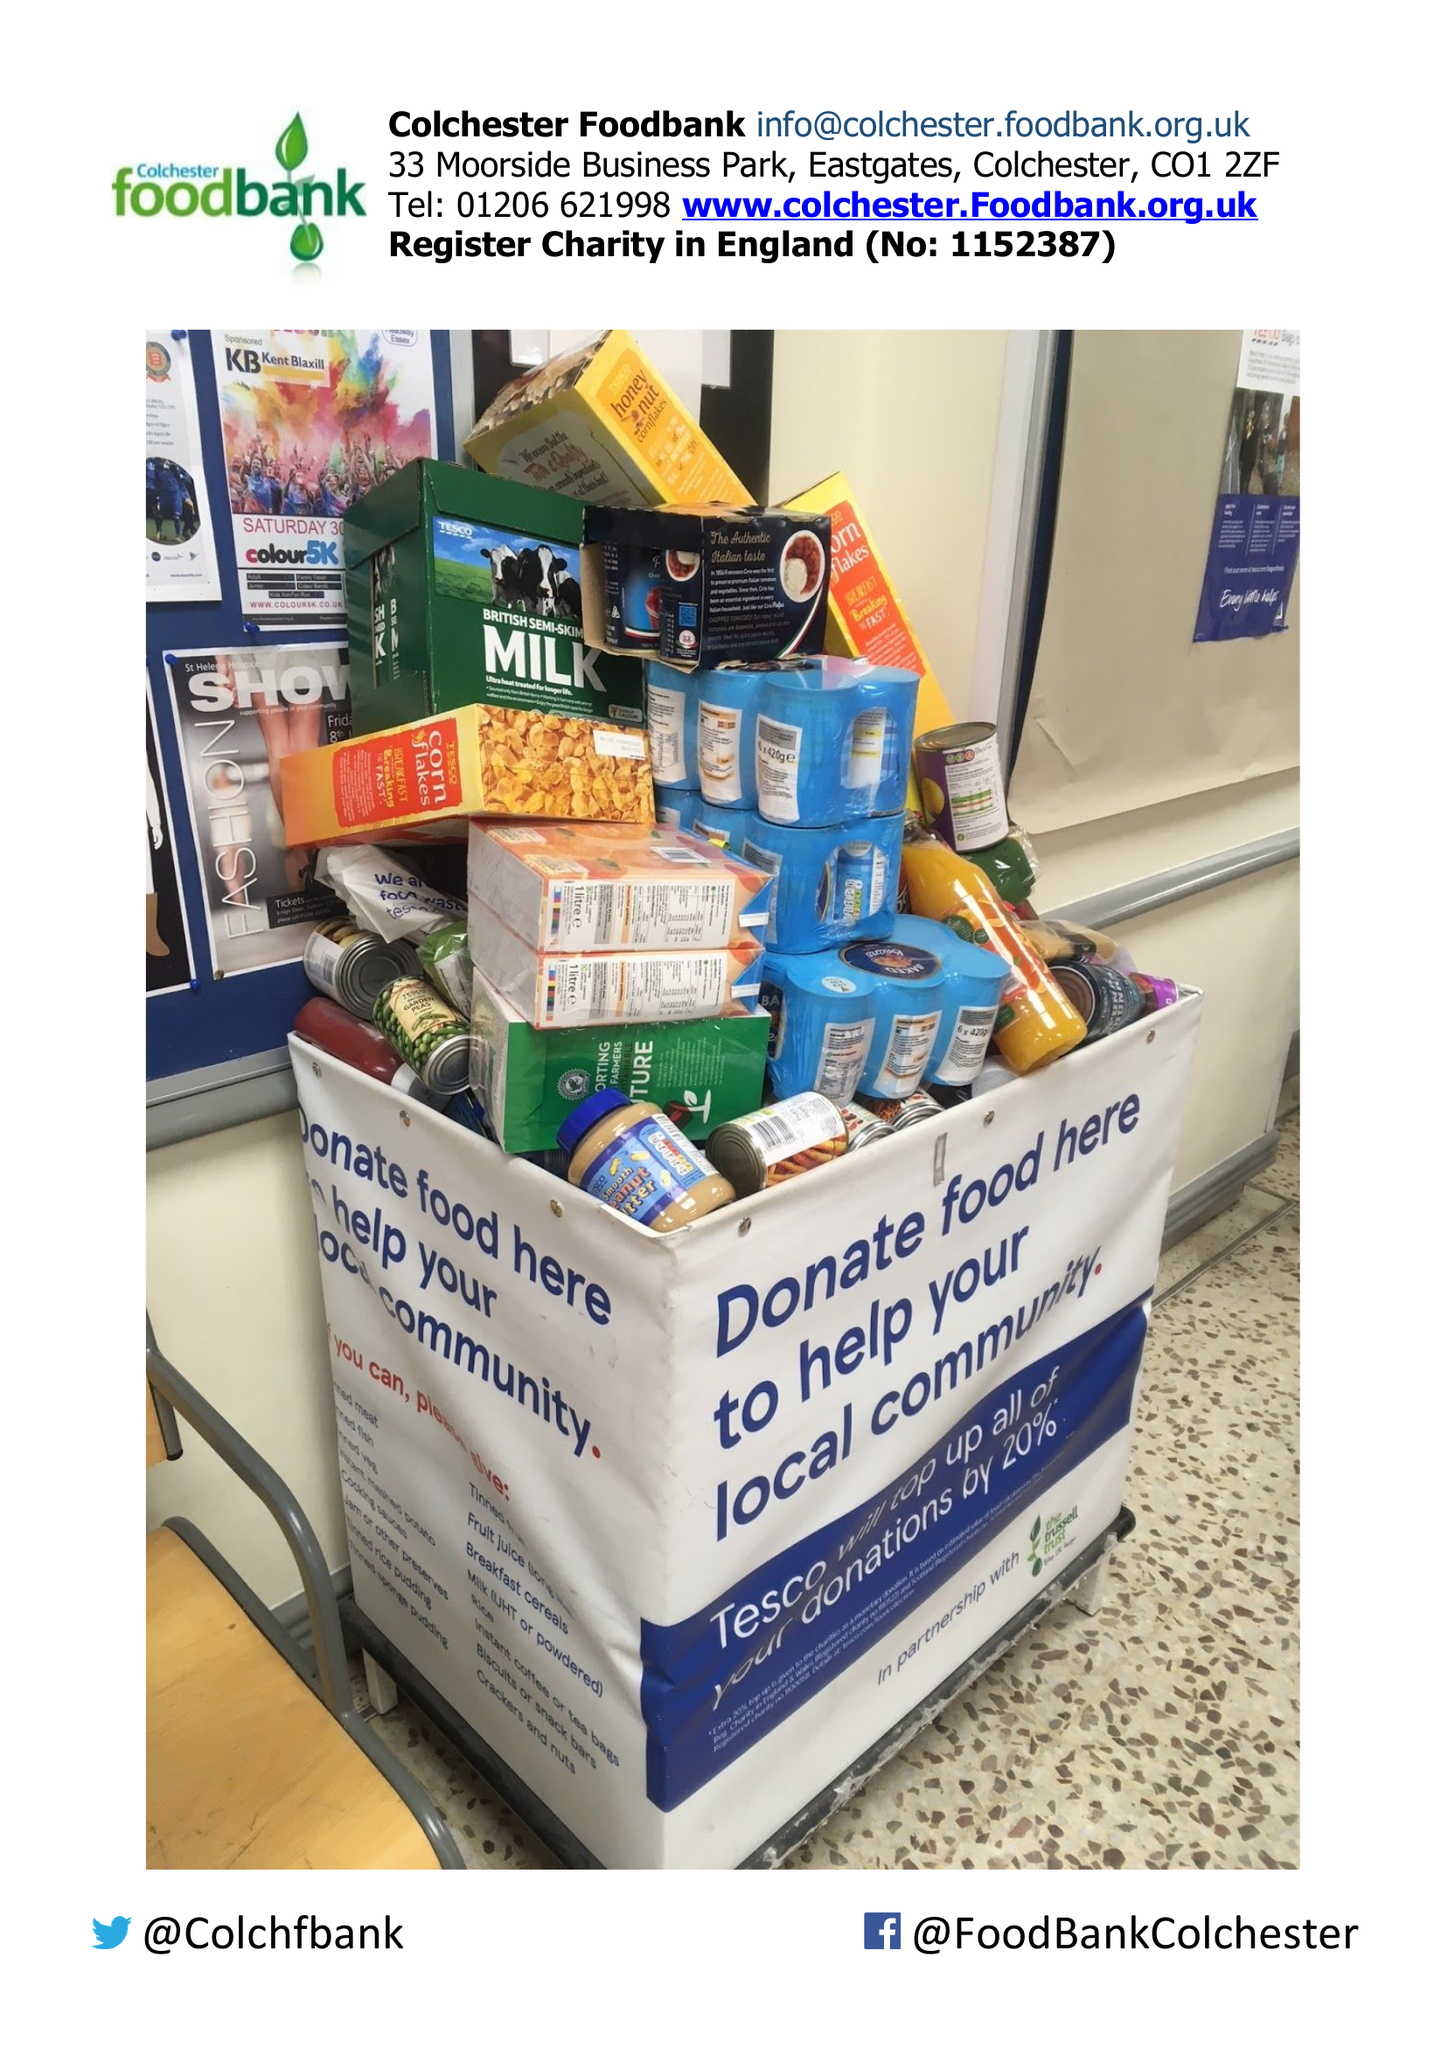What is the value for the charity_number?
Answer the question using a single word or phrase. 1152387 